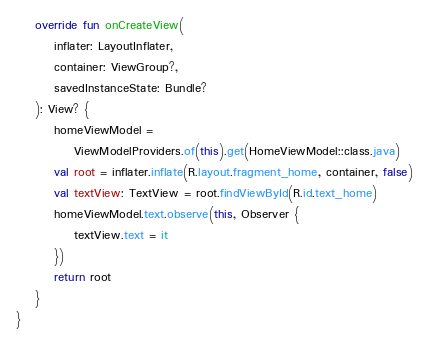<code> <loc_0><loc_0><loc_500><loc_500><_Kotlin_>
    override fun onCreateView(
        inflater: LayoutInflater,
        container: ViewGroup?,
        savedInstanceState: Bundle?
    ): View? {
        homeViewModel =
            ViewModelProviders.of(this).get(HomeViewModel::class.java)
        val root = inflater.inflate(R.layout.fragment_home, container, false)
        val textView: TextView = root.findViewById(R.id.text_home)
        homeViewModel.text.observe(this, Observer {
            textView.text = it
        })
        return root
    }
}</code> 